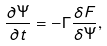<formula> <loc_0><loc_0><loc_500><loc_500>\frac { \partial \Psi } { \partial t } = - \Gamma \frac { \delta F } { \delta \Psi } ,</formula> 